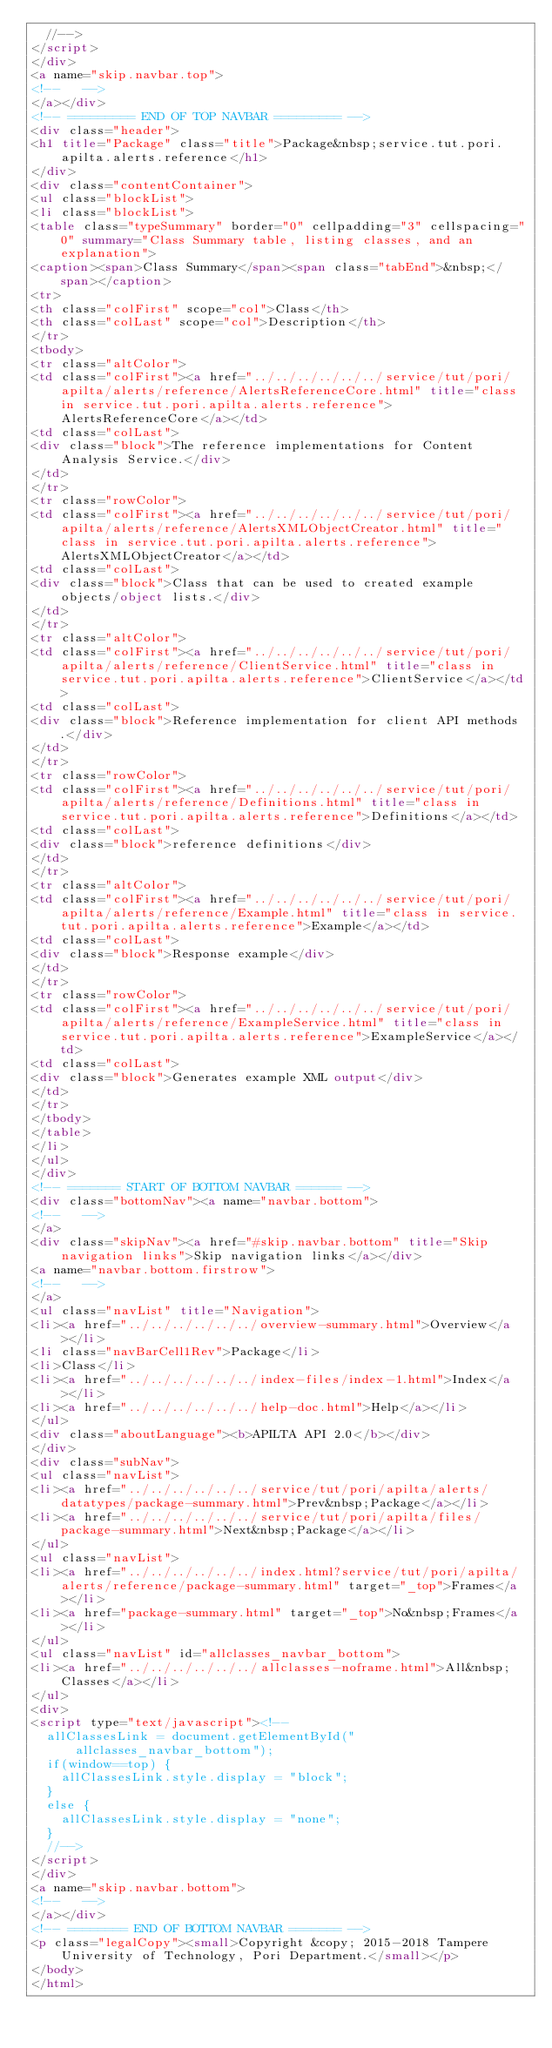<code> <loc_0><loc_0><loc_500><loc_500><_HTML_>  //-->
</script>
</div>
<a name="skip.navbar.top">
<!--   -->
</a></div>
<!-- ========= END OF TOP NAVBAR ========= -->
<div class="header">
<h1 title="Package" class="title">Package&nbsp;service.tut.pori.apilta.alerts.reference</h1>
</div>
<div class="contentContainer">
<ul class="blockList">
<li class="blockList">
<table class="typeSummary" border="0" cellpadding="3" cellspacing="0" summary="Class Summary table, listing classes, and an explanation">
<caption><span>Class Summary</span><span class="tabEnd">&nbsp;</span></caption>
<tr>
<th class="colFirst" scope="col">Class</th>
<th class="colLast" scope="col">Description</th>
</tr>
<tbody>
<tr class="altColor">
<td class="colFirst"><a href="../../../../../../service/tut/pori/apilta/alerts/reference/AlertsReferenceCore.html" title="class in service.tut.pori.apilta.alerts.reference">AlertsReferenceCore</a></td>
<td class="colLast">
<div class="block">The reference implementations for Content Analysis Service.</div>
</td>
</tr>
<tr class="rowColor">
<td class="colFirst"><a href="../../../../../../service/tut/pori/apilta/alerts/reference/AlertsXMLObjectCreator.html" title="class in service.tut.pori.apilta.alerts.reference">AlertsXMLObjectCreator</a></td>
<td class="colLast">
<div class="block">Class that can be used to created example objects/object lists.</div>
</td>
</tr>
<tr class="altColor">
<td class="colFirst"><a href="../../../../../../service/tut/pori/apilta/alerts/reference/ClientService.html" title="class in service.tut.pori.apilta.alerts.reference">ClientService</a></td>
<td class="colLast">
<div class="block">Reference implementation for client API methods.</div>
</td>
</tr>
<tr class="rowColor">
<td class="colFirst"><a href="../../../../../../service/tut/pori/apilta/alerts/reference/Definitions.html" title="class in service.tut.pori.apilta.alerts.reference">Definitions</a></td>
<td class="colLast">
<div class="block">reference definitions</div>
</td>
</tr>
<tr class="altColor">
<td class="colFirst"><a href="../../../../../../service/tut/pori/apilta/alerts/reference/Example.html" title="class in service.tut.pori.apilta.alerts.reference">Example</a></td>
<td class="colLast">
<div class="block">Response example</div>
</td>
</tr>
<tr class="rowColor">
<td class="colFirst"><a href="../../../../../../service/tut/pori/apilta/alerts/reference/ExampleService.html" title="class in service.tut.pori.apilta.alerts.reference">ExampleService</a></td>
<td class="colLast">
<div class="block">Generates example XML output</div>
</td>
</tr>
</tbody>
</table>
</li>
</ul>
</div>
<!-- ======= START OF BOTTOM NAVBAR ====== -->
<div class="bottomNav"><a name="navbar.bottom">
<!--   -->
</a>
<div class="skipNav"><a href="#skip.navbar.bottom" title="Skip navigation links">Skip navigation links</a></div>
<a name="navbar.bottom.firstrow">
<!--   -->
</a>
<ul class="navList" title="Navigation">
<li><a href="../../../../../../overview-summary.html">Overview</a></li>
<li class="navBarCell1Rev">Package</li>
<li>Class</li>
<li><a href="../../../../../../index-files/index-1.html">Index</a></li>
<li><a href="../../../../../../help-doc.html">Help</a></li>
</ul>
<div class="aboutLanguage"><b>APILTA API 2.0</b></div>
</div>
<div class="subNav">
<ul class="navList">
<li><a href="../../../../../../service/tut/pori/apilta/alerts/datatypes/package-summary.html">Prev&nbsp;Package</a></li>
<li><a href="../../../../../../service/tut/pori/apilta/files/package-summary.html">Next&nbsp;Package</a></li>
</ul>
<ul class="navList">
<li><a href="../../../../../../index.html?service/tut/pori/apilta/alerts/reference/package-summary.html" target="_top">Frames</a></li>
<li><a href="package-summary.html" target="_top">No&nbsp;Frames</a></li>
</ul>
<ul class="navList" id="allclasses_navbar_bottom">
<li><a href="../../../../../../allclasses-noframe.html">All&nbsp;Classes</a></li>
</ul>
<div>
<script type="text/javascript"><!--
  allClassesLink = document.getElementById("allclasses_navbar_bottom");
  if(window==top) {
    allClassesLink.style.display = "block";
  }
  else {
    allClassesLink.style.display = "none";
  }
  //-->
</script>
</div>
<a name="skip.navbar.bottom">
<!--   -->
</a></div>
<!-- ======== END OF BOTTOM NAVBAR ======= -->
<p class="legalCopy"><small>Copyright &copy; 2015-2018 Tampere University of Technology, Pori Department.</small></p>
</body>
</html>
</code> 